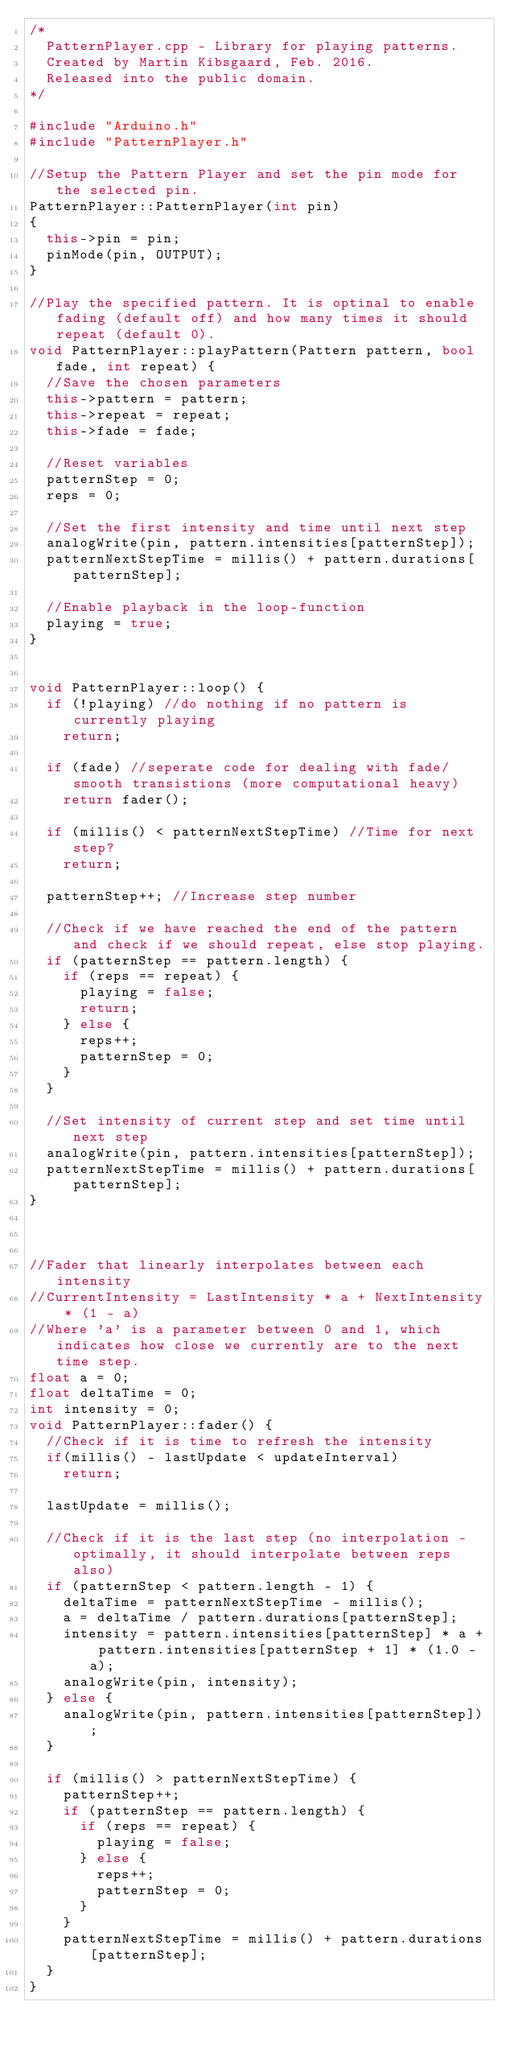<code> <loc_0><loc_0><loc_500><loc_500><_C++_>/*
  PatternPlayer.cpp - Library for playing patterns.
  Created by Martin Kibsgaard, Feb. 2016.
  Released into the public domain.
*/

#include "Arduino.h"
#include "PatternPlayer.h"

//Setup the Pattern Player and set the pin mode for the selected pin.
PatternPlayer::PatternPlayer(int pin)
{
  this->pin = pin;
  pinMode(pin, OUTPUT);
}

//Play the specified pattern. It is optinal to enable fading (default off) and how many times it should repeat (default 0).
void PatternPlayer::playPattern(Pattern pattern, bool fade, int repeat) {
  //Save the chosen parameters
  this->pattern = pattern;
  this->repeat = repeat;
  this->fade = fade;
  
  //Reset variables
  patternStep = 0;
  reps = 0;

  //Set the first intensity and time until next step
  analogWrite(pin, pattern.intensities[patternStep]);
  patternNextStepTime = millis() + pattern.durations[patternStep];

  //Enable playback in the loop-function
  playing = true;
}


void PatternPlayer::loop() {
  if (!playing) //do nothing if no pattern is currently playing
    return;

  if (fade) //seperate code for dealing with fade/smooth transistions (more computational heavy)
    return fader();

  if (millis() < patternNextStepTime) //Time for next step?
    return;

  patternStep++; //Increase step number

  //Check if we have reached the end of the pattern and check if we should repeat, else stop playing.
  if (patternStep == pattern.length) {
    if (reps == repeat) {
      playing = false;
      return;
    } else {
      reps++;
      patternStep = 0;
    }
  }

  //Set intensity of current step and set time until next step
  analogWrite(pin, pattern.intensities[patternStep]);
  patternNextStepTime = millis() + pattern.durations[patternStep];
}



//Fader that linearly interpolates between each intensity
//CurrentIntensity = LastIntensity * a + NextIntensity * (1 - a)
//Where 'a' is a parameter between 0 and 1, which indicates how close we currently are to the next time step.
float a = 0;
float deltaTime = 0;
int intensity = 0;
void PatternPlayer::fader() {
  //Check if it is time to refresh the intensity
  if(millis() - lastUpdate < updateInterval)
    return;

  lastUpdate = millis();
  
  //Check if it is the last step (no interpolation - optimally, it should interpolate between reps also)
  if (patternStep < pattern.length - 1) {
    deltaTime = patternNextStepTime - millis();
    a = deltaTime / pattern.durations[patternStep];
    intensity = pattern.intensities[patternStep] * a + pattern.intensities[patternStep + 1] * (1.0 - a);
    analogWrite(pin, intensity);
  } else {
    analogWrite(pin, pattern.intensities[patternStep]);
  }

  if (millis() > patternNextStepTime) {
    patternStep++;
    if (patternStep == pattern.length) {
      if (reps == repeat) {
        playing = false;
      } else {
        reps++;
        patternStep = 0;
      }
    }
    patternNextStepTime = millis() + pattern.durations[patternStep];
  }
}


</code> 